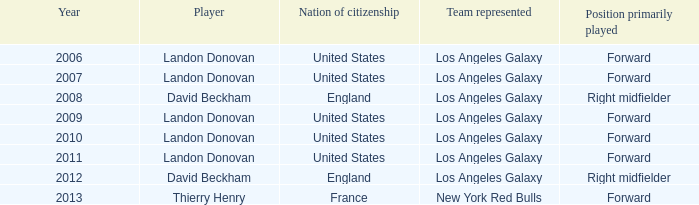What is the sum of all the years that Landon Donovan won the ESPY award? 5.0. 